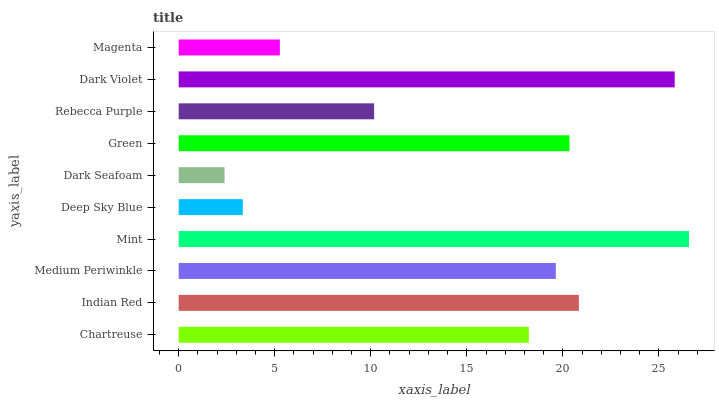Is Dark Seafoam the minimum?
Answer yes or no. Yes. Is Mint the maximum?
Answer yes or no. Yes. Is Indian Red the minimum?
Answer yes or no. No. Is Indian Red the maximum?
Answer yes or no. No. Is Indian Red greater than Chartreuse?
Answer yes or no. Yes. Is Chartreuse less than Indian Red?
Answer yes or no. Yes. Is Chartreuse greater than Indian Red?
Answer yes or no. No. Is Indian Red less than Chartreuse?
Answer yes or no. No. Is Medium Periwinkle the high median?
Answer yes or no. Yes. Is Chartreuse the low median?
Answer yes or no. Yes. Is Dark Seafoam the high median?
Answer yes or no. No. Is Dark Violet the low median?
Answer yes or no. No. 